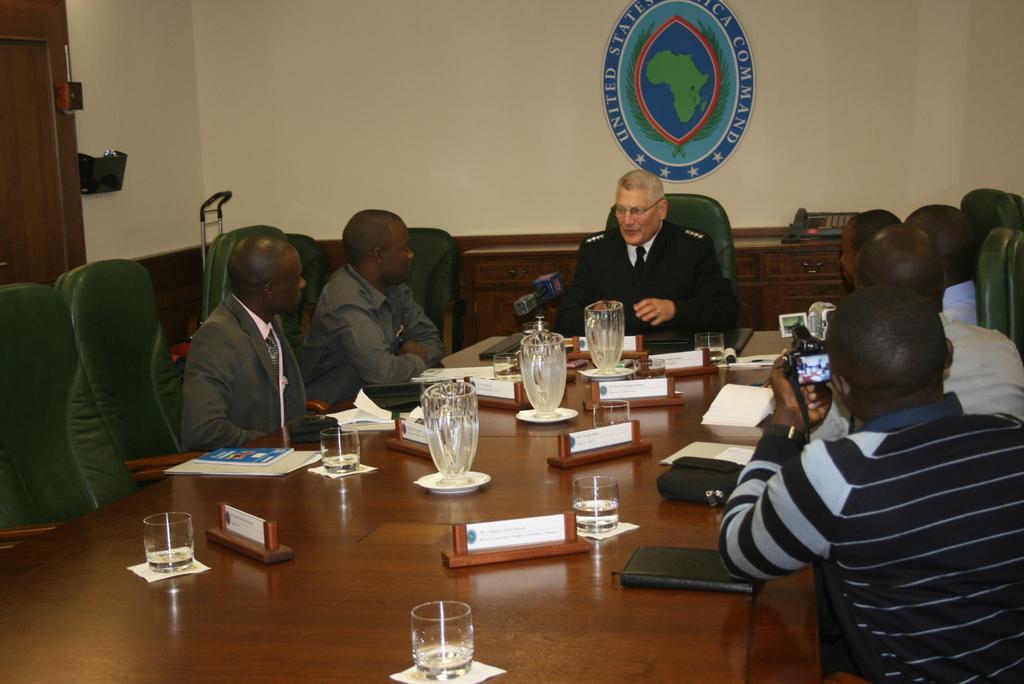How would you summarize this image in a sentence or two? There are few people sitting on the chair at the table and listening to the middle person talking. On the table there are glasses,mugs and books. 